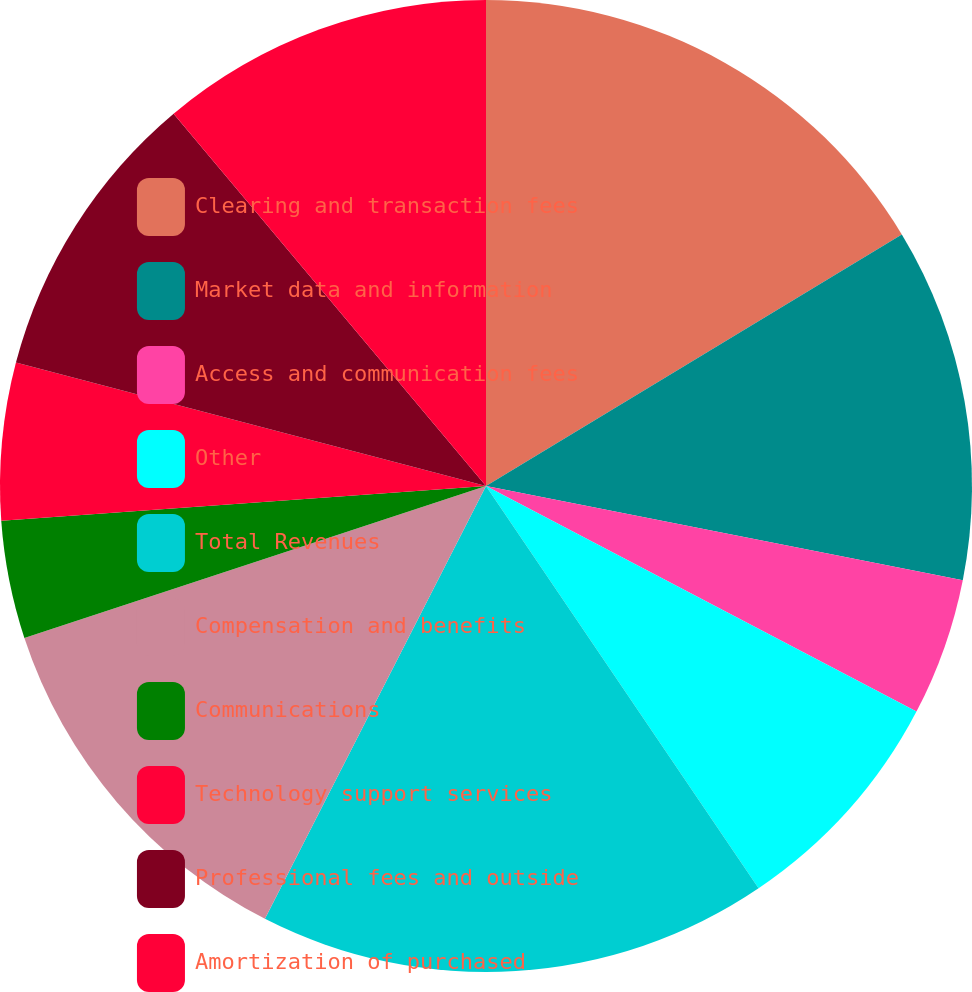Convert chart to OTSL. <chart><loc_0><loc_0><loc_500><loc_500><pie_chart><fcel>Clearing and transaction fees<fcel>Market data and information<fcel>Access and communication fees<fcel>Other<fcel>Total Revenues<fcel>Compensation and benefits<fcel>Communications<fcel>Technology support services<fcel>Professional fees and outside<fcel>Amortization of purchased<nl><fcel>16.34%<fcel>11.76%<fcel>4.58%<fcel>7.84%<fcel>16.99%<fcel>12.42%<fcel>3.92%<fcel>5.23%<fcel>9.8%<fcel>11.11%<nl></chart> 